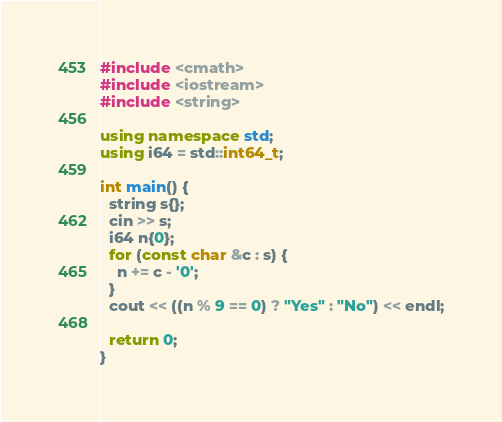Convert code to text. <code><loc_0><loc_0><loc_500><loc_500><_C++_>#include <cmath>
#include <iostream>
#include <string>

using namespace std;
using i64 = std::int64_t;

int main() {
  string s{};
  cin >> s;
  i64 n{0};
  for (const char &c : s) {
    n += c - '0';
  }
  cout << ((n % 9 == 0) ? "Yes" : "No") << endl;

  return 0;
}
</code> 